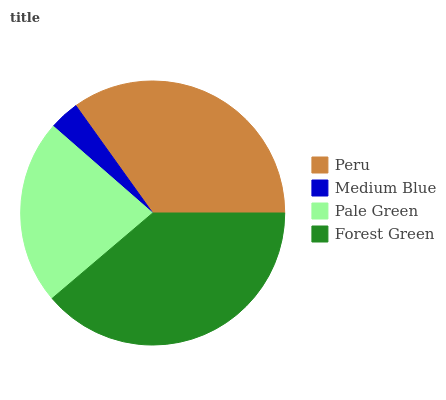Is Medium Blue the minimum?
Answer yes or no. Yes. Is Forest Green the maximum?
Answer yes or no. Yes. Is Pale Green the minimum?
Answer yes or no. No. Is Pale Green the maximum?
Answer yes or no. No. Is Pale Green greater than Medium Blue?
Answer yes or no. Yes. Is Medium Blue less than Pale Green?
Answer yes or no. Yes. Is Medium Blue greater than Pale Green?
Answer yes or no. No. Is Pale Green less than Medium Blue?
Answer yes or no. No. Is Peru the high median?
Answer yes or no. Yes. Is Pale Green the low median?
Answer yes or no. Yes. Is Medium Blue the high median?
Answer yes or no. No. Is Forest Green the low median?
Answer yes or no. No. 